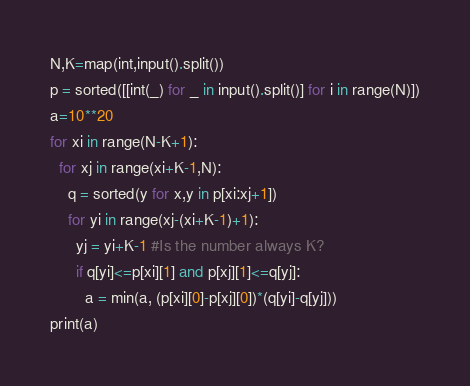<code> <loc_0><loc_0><loc_500><loc_500><_Python_>N,K=map(int,input().split())
p = sorted([[int(_) for _ in input().split()] for i in range(N)])
a=10**20
for xi in range(N-K+1):
  for xj in range(xi+K-1,N):
    q = sorted(y for x,y in p[xi:xj+1])
    for yi in range(xj-(xi+K-1)+1):
      yj = yi+K-1 #Is the number always K?
      if q[yi]<=p[xi][1] and p[xj][1]<=q[yj]:
        a = min(a, (p[xi][0]-p[xj][0])*(q[yi]-q[yj]))
print(a)
</code> 